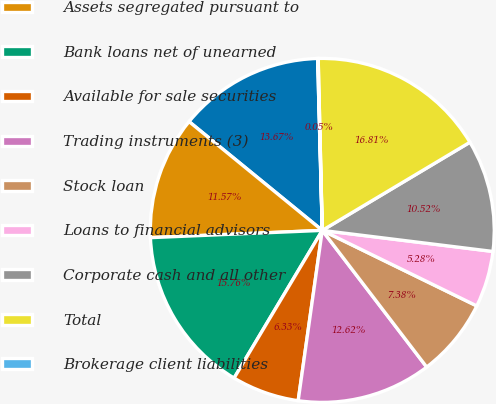<chart> <loc_0><loc_0><loc_500><loc_500><pie_chart><fcel>Margin balances<fcel>Assets segregated pursuant to<fcel>Bank loans net of unearned<fcel>Available for sale securities<fcel>Trading instruments (3)<fcel>Stock loan<fcel>Loans to financial advisors<fcel>Corporate cash and all other<fcel>Total<fcel>Brokerage client liabilities<nl><fcel>13.67%<fcel>11.57%<fcel>15.76%<fcel>6.33%<fcel>12.62%<fcel>7.38%<fcel>5.28%<fcel>10.52%<fcel>16.81%<fcel>0.05%<nl></chart> 